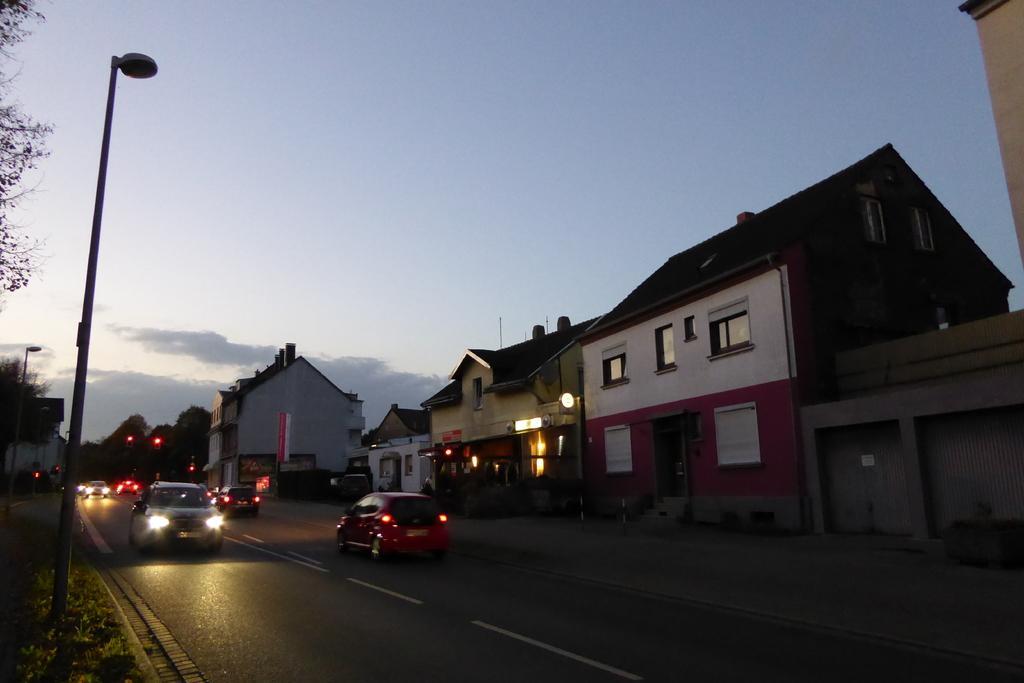Can you describe this image briefly? This image is taken outdoors. At the top of the image there is the sky with clouds. At the bottom of the there is a road. On the left side of the image there are few trees and there is a house. There is a pole with a street light. In the background there are a few trees. In the middle of the image a few cars are moving on the road. There are a few houses with walls, windows, doors and roofs. There are a few lights. 